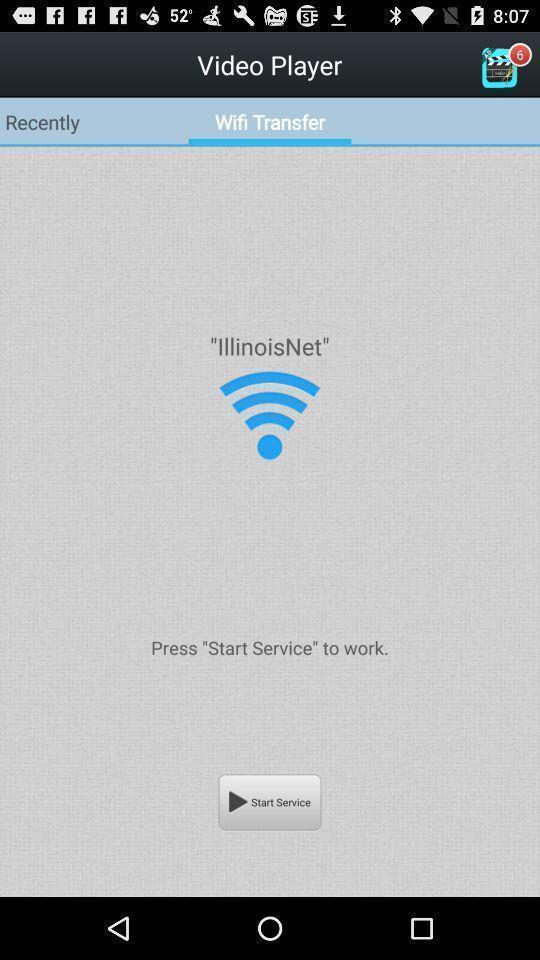Tell me what you see in this picture. Screen shows wifi transfer in media player app. 